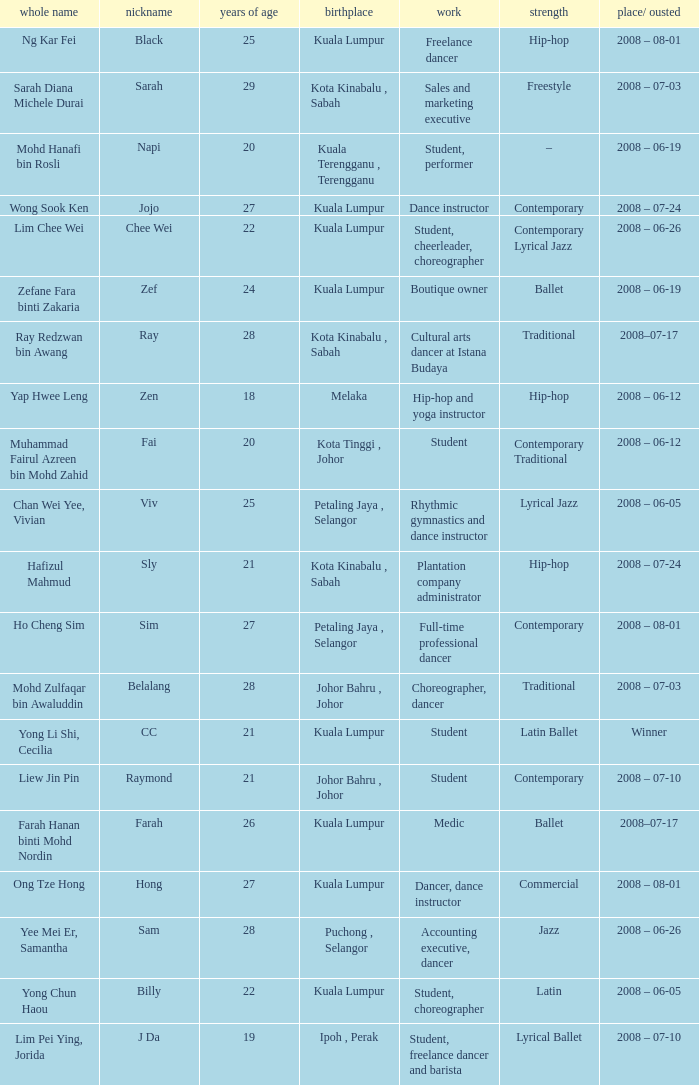What is Occupation², when Age¹ is greater than 24, when Alias is "Black"? Freelance dancer. 